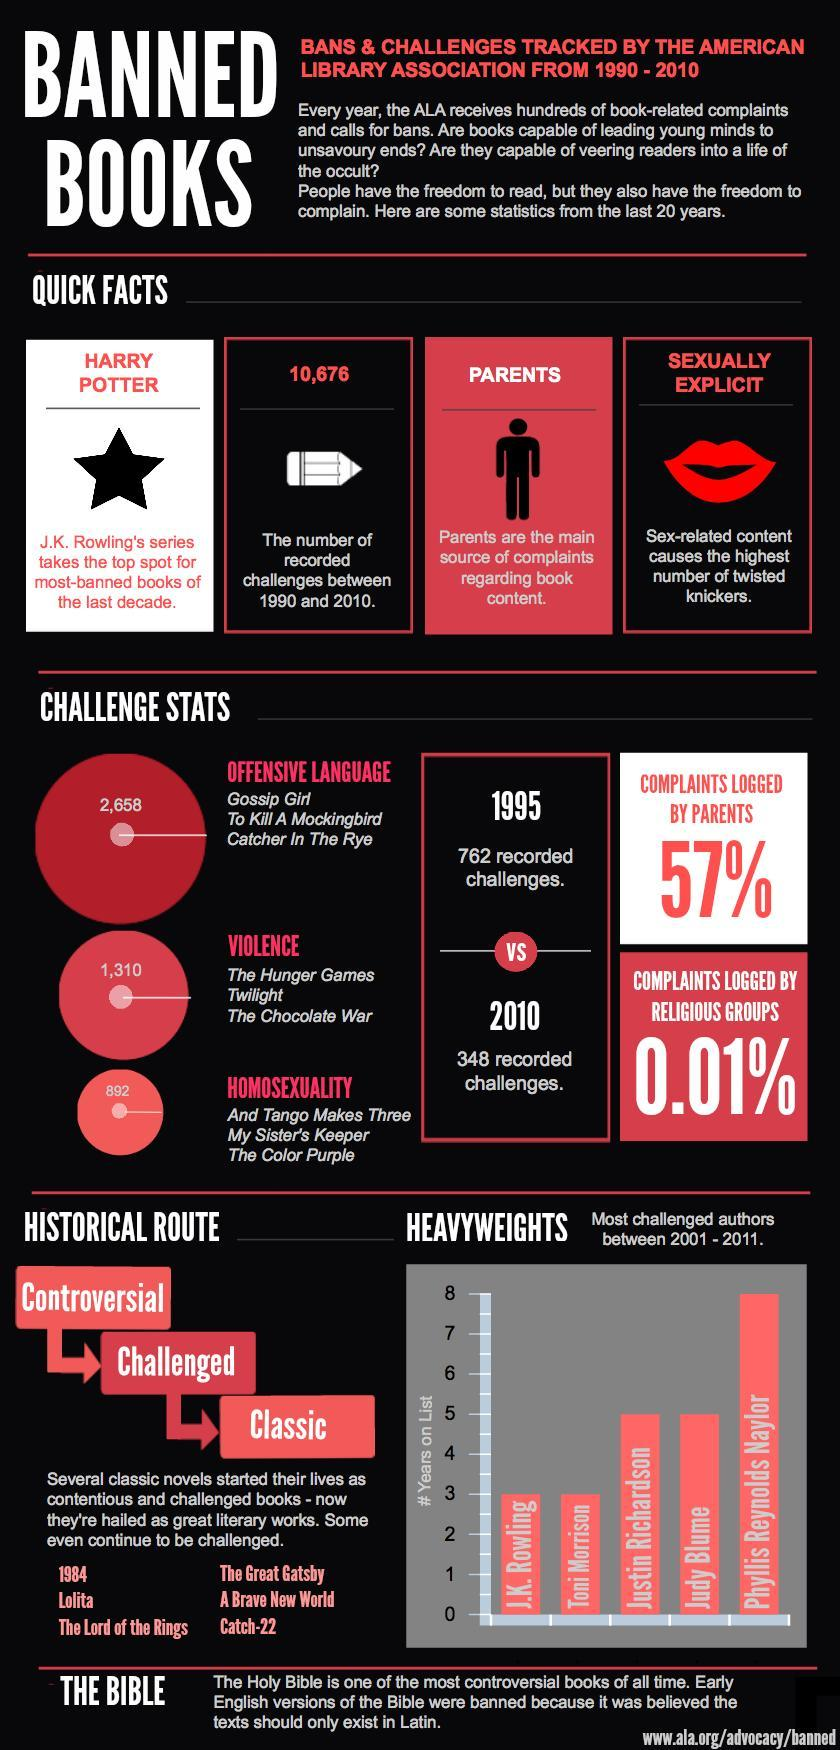Why was the book ' The Color Purple' challenged?
Answer the question with a short phrase. HOMOSEXUALITY How many challenges were recorded for the book 'Gossip Girl'? 2,658 What is the main reason for book challenges & bans during 1990-2010? SEXUALLY EXPLICIT What is the number of recorded challenges between 1990 & 2010? 10,676 Who is the most challenged author between 2001-2011? Phyllis Reynolds Naylor Why was the book ' The Hunger Games' challenged? VIOLENCE 